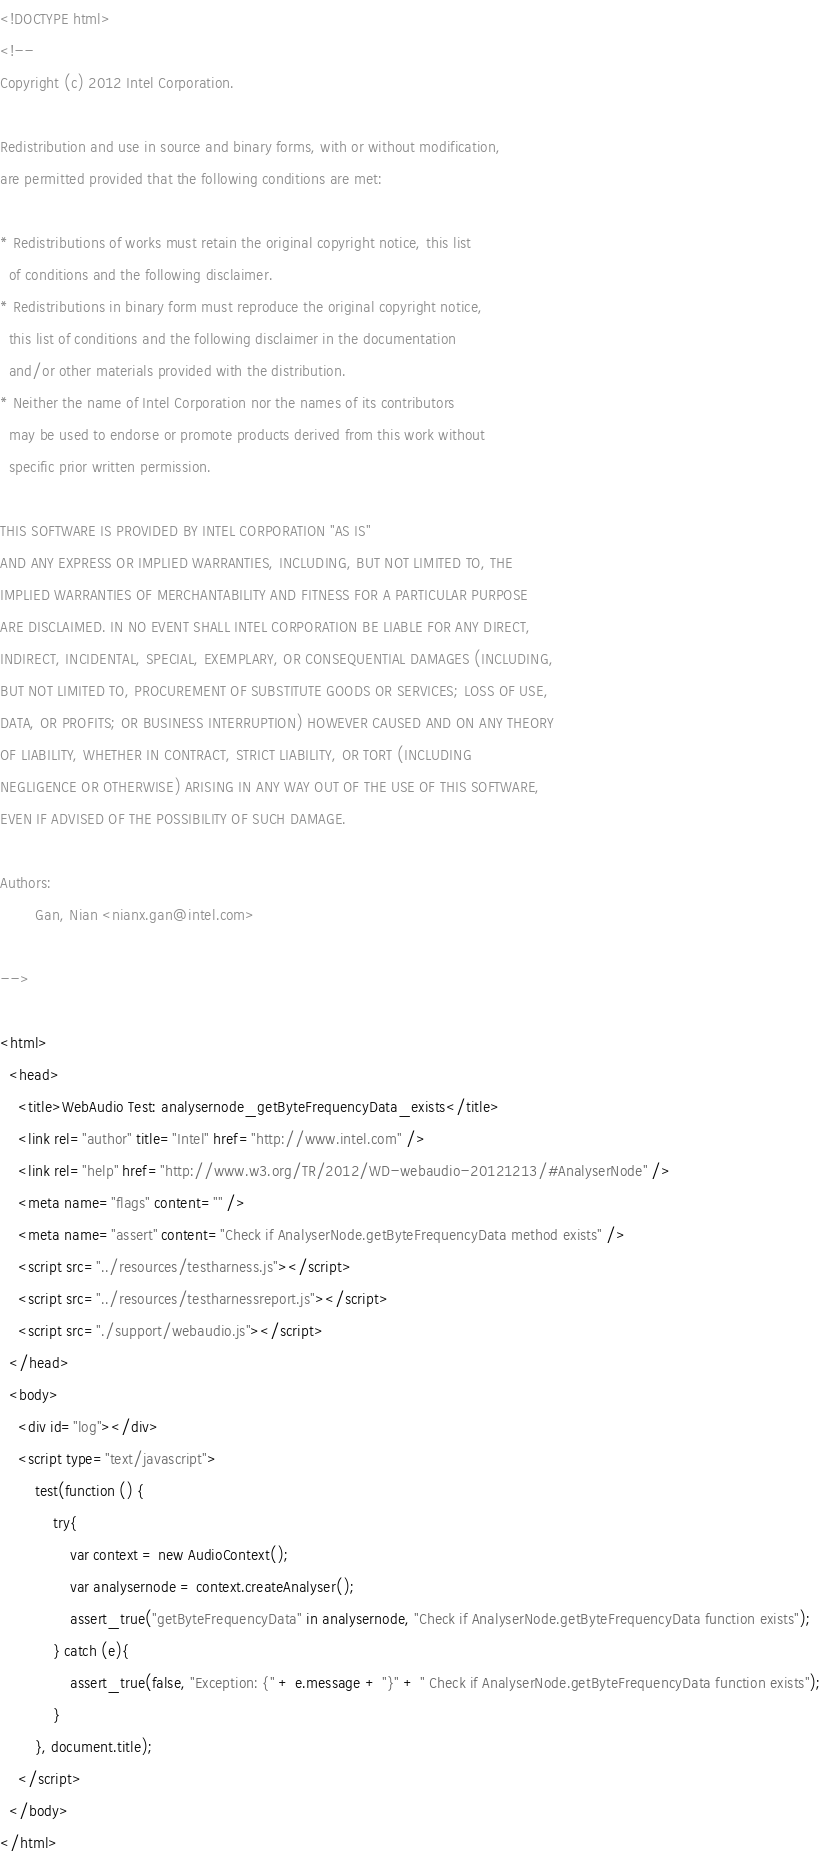<code> <loc_0><loc_0><loc_500><loc_500><_HTML_><!DOCTYPE html>
<!--
Copyright (c) 2012 Intel Corporation.

Redistribution and use in source and binary forms, with or without modification,
are permitted provided that the following conditions are met:

* Redistributions of works must retain the original copyright notice, this list
  of conditions and the following disclaimer.
* Redistributions in binary form must reproduce the original copyright notice,
  this list of conditions and the following disclaimer in the documentation
  and/or other materials provided with the distribution.
* Neither the name of Intel Corporation nor the names of its contributors
  may be used to endorse or promote products derived from this work without
  specific prior written permission.

THIS SOFTWARE IS PROVIDED BY INTEL CORPORATION "AS IS"
AND ANY EXPRESS OR IMPLIED WARRANTIES, INCLUDING, BUT NOT LIMITED TO, THE
IMPLIED WARRANTIES OF MERCHANTABILITY AND FITNESS FOR A PARTICULAR PURPOSE
ARE DISCLAIMED. IN NO EVENT SHALL INTEL CORPORATION BE LIABLE FOR ANY DIRECT,
INDIRECT, INCIDENTAL, SPECIAL, EXEMPLARY, OR CONSEQUENTIAL DAMAGES (INCLUDING,
BUT NOT LIMITED TO, PROCUREMENT OF SUBSTITUTE GOODS OR SERVICES; LOSS OF USE,
DATA, OR PROFITS; OR BUSINESS INTERRUPTION) HOWEVER CAUSED AND ON ANY THEORY
OF LIABILITY, WHETHER IN CONTRACT, STRICT LIABILITY, OR TORT (INCLUDING
NEGLIGENCE OR OTHERWISE) ARISING IN ANY WAY OUT OF THE USE OF THIS SOFTWARE,
EVEN IF ADVISED OF THE POSSIBILITY OF SUCH DAMAGE.

Authors:
        Gan, Nian <nianx.gan@intel.com>

-->

<html>
  <head>
    <title>WebAudio Test: analysernode_getByteFrequencyData_exists</title>
    <link rel="author" title="Intel" href="http://www.intel.com" />
    <link rel="help" href="http://www.w3.org/TR/2012/WD-webaudio-20121213/#AnalyserNode" />
    <meta name="flags" content="" />
    <meta name="assert" content="Check if AnalyserNode.getByteFrequencyData method exists" />
    <script src="../resources/testharness.js"></script>
    <script src="../resources/testharnessreport.js"></script>
    <script src="./support/webaudio.js"></script>
  </head>
  <body>
    <div id="log"></div>
    <script type="text/javascript">
        test(function () {
            try{
                var context = new AudioContext();
                var analysernode = context.createAnalyser();
                assert_true("getByteFrequencyData" in analysernode, "Check if AnalyserNode.getByteFrequencyData function exists");
            } catch (e){
                assert_true(false, "Exception: {" + e.message + "}" + " Check if AnalyserNode.getByteFrequencyData function exists");
            }
        }, document.title);
    </script>
  </body>
</html>
</code> 